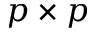<formula> <loc_0><loc_0><loc_500><loc_500>p \times p</formula> 